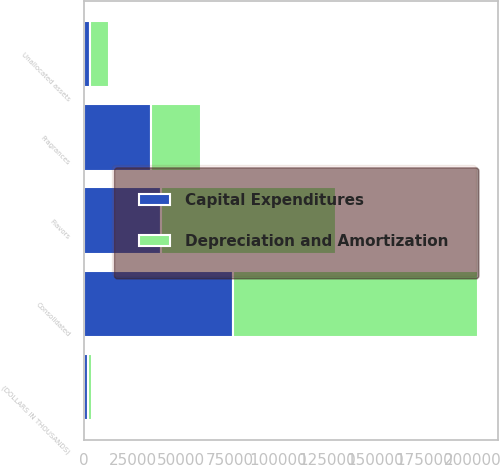Convert chart. <chart><loc_0><loc_0><loc_500><loc_500><stacked_bar_chart><ecel><fcel>(DOLLARS IN THOUSANDS)<fcel>Flavors<fcel>Fragrances<fcel>Unallocated assets<fcel>Consolidated<nl><fcel>Depreciation and Amortization<fcel>2012<fcel>90309<fcel>26069<fcel>9762<fcel>126140<nl><fcel>Capital Expenditures<fcel>2012<fcel>39565<fcel>34238<fcel>2864<fcel>76667<nl></chart> 